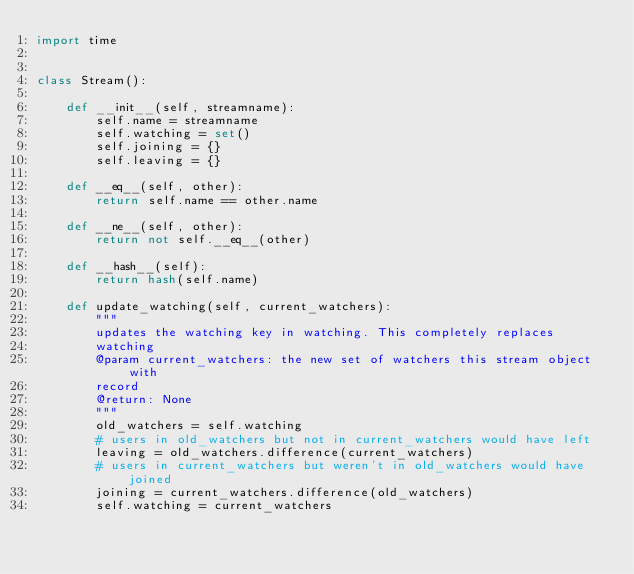Convert code to text. <code><loc_0><loc_0><loc_500><loc_500><_Python_>import time


class Stream():

    def __init__(self, streamname):
        self.name = streamname
        self.watching = set()
        self.joining = {}
        self.leaving = {}

    def __eq__(self, other):
        return self.name == other.name

    def __ne__(self, other):
        return not self.__eq__(other)

    def __hash__(self):
        return hash(self.name)

    def update_watching(self, current_watchers):
        """
        updates the watching key in watching. This completely replaces
        watching
        @param current_watchers: the new set of watchers this stream object with
        record
        @return: None
        """
        old_watchers = self.watching
        # users in old_watchers but not in current_watchers would have left
        leaving = old_watchers.difference(current_watchers)
        # users in current_watchers but weren't in old_watchers would have joined
        joining = current_watchers.difference(old_watchers)
        self.watching = current_watchers</code> 